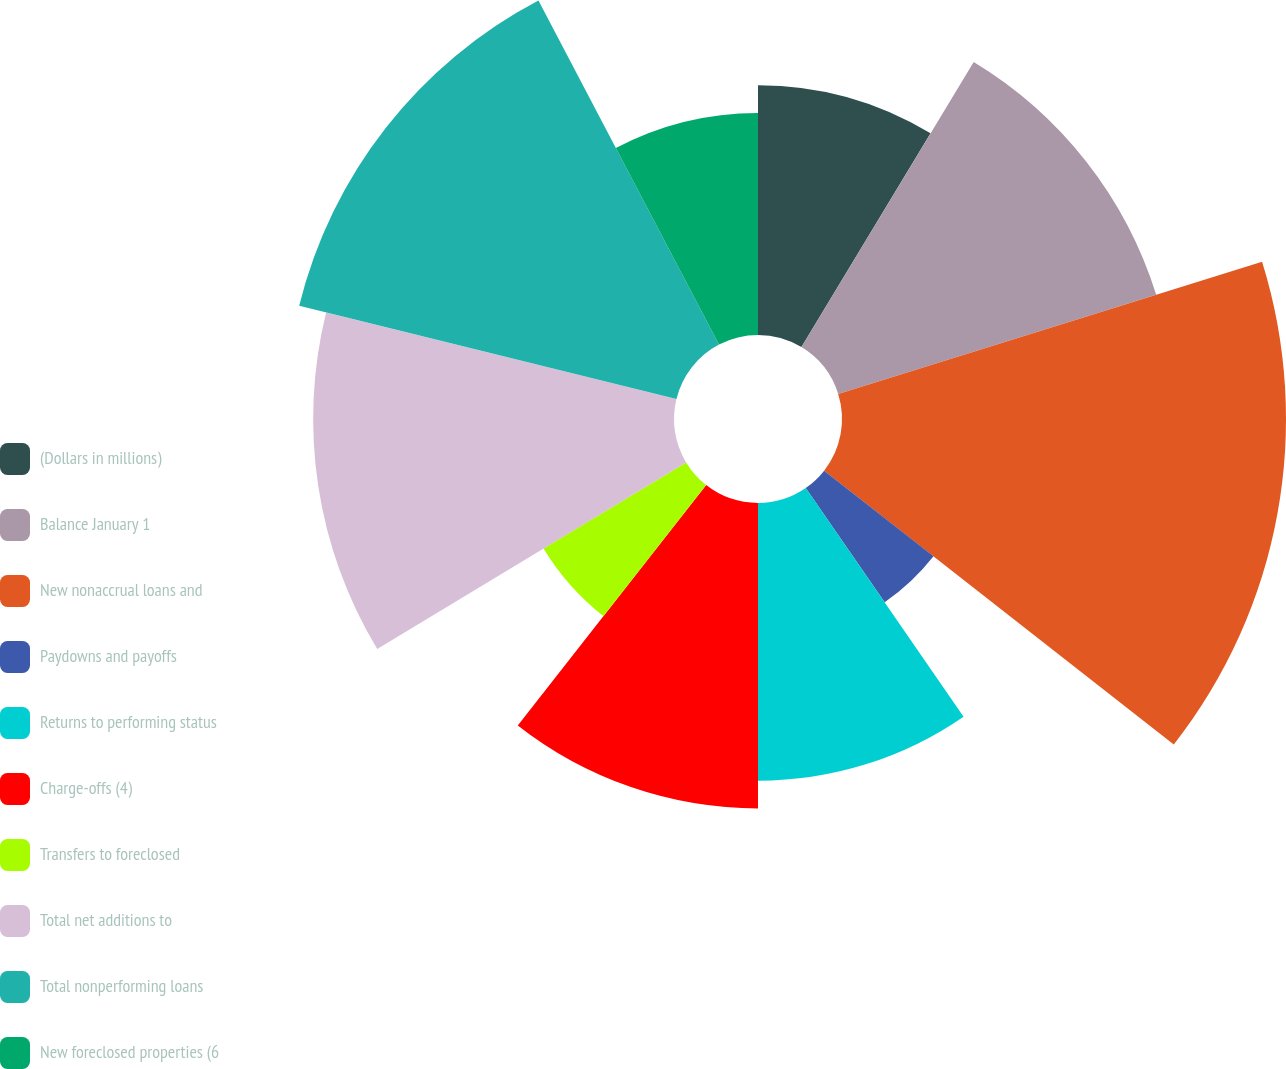Convert chart to OTSL. <chart><loc_0><loc_0><loc_500><loc_500><pie_chart><fcel>(Dollars in millions)<fcel>Balance January 1<fcel>New nonaccrual loans and<fcel>Paydowns and payoffs<fcel>Returns to performing status<fcel>Charge-offs (4)<fcel>Transfers to foreclosed<fcel>Total net additions to<fcel>Total nonperforming loans<fcel>New foreclosed properties (6<nl><fcel>8.65%<fcel>11.54%<fcel>15.38%<fcel>4.81%<fcel>9.62%<fcel>10.58%<fcel>5.77%<fcel>12.5%<fcel>13.46%<fcel>7.69%<nl></chart> 